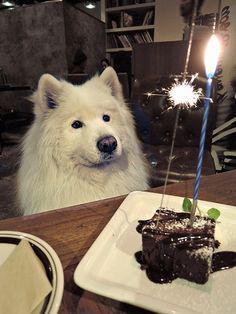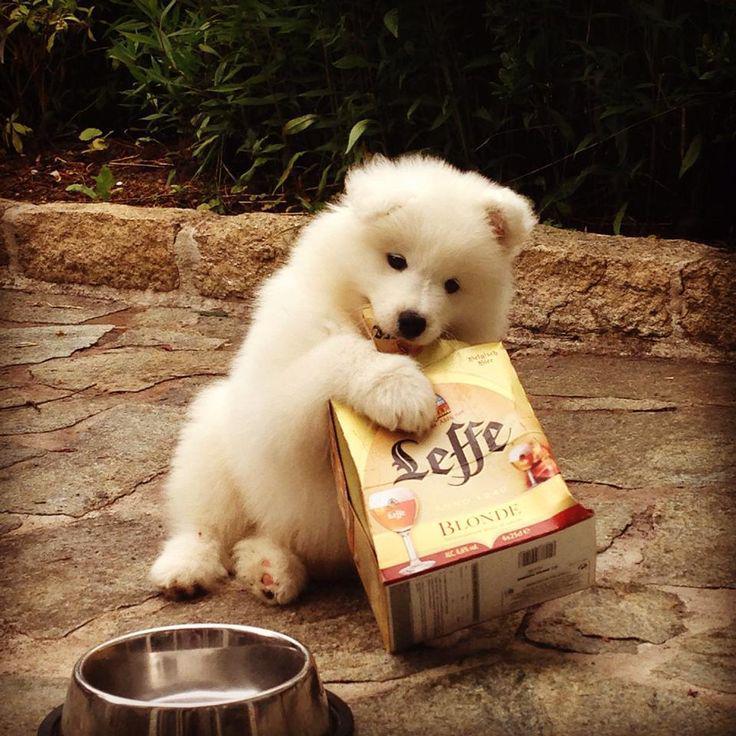The first image is the image on the left, the second image is the image on the right. Evaluate the accuracy of this statement regarding the images: "At least one dog is laying on a couch.". Is it true? Answer yes or no. No. The first image is the image on the left, the second image is the image on the right. Evaluate the accuracy of this statement regarding the images: "Each image contains exactly one white dog, and at least one image shows a dog in a setting with furniture.". Is it true? Answer yes or no. Yes. 